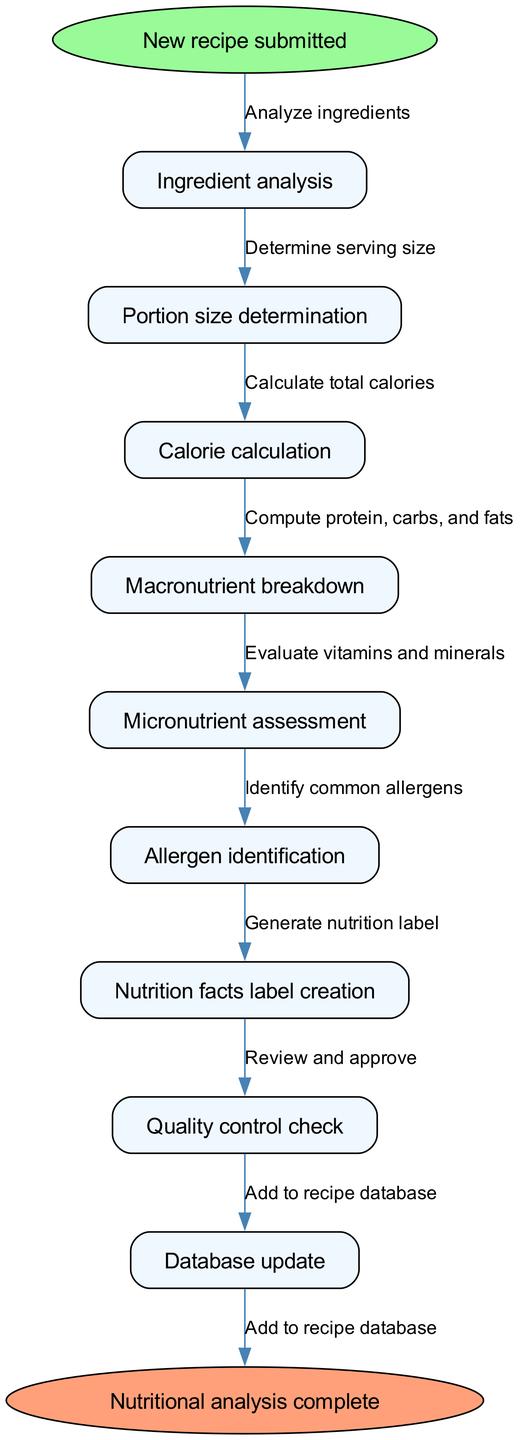What is the first step in the nutritional analysis process? The first step in the process is represented by the start node, which indicates that the "New recipe submitted" marks the beginning of the analysis.
Answer: New recipe submitted How many nodes are there in total? The diagram lists a total of 9 nodes, including the start and end nodes. This includes 7 process nodes and 2 terminal nodes.
Answer: 9 What is the last step before completion? The last step before reaching the end of the flowchart is the "Quality control check" node, which is the second to last node in the sequence.
Answer: Quality control check What is the focus of the “Micronutrient assessment” node? The “Micronutrient assessment” step evaluates specific vitamins and minerals present in the ingredients of the new recipe.
Answer: Vitamins and minerals Which process node follows 'Calorie calculation'? The node that follows 'Calorie calculation' is 'Macronutrient breakdown', indicating the next stage in the analysis after calories have been computed.
Answer: Macronutrient breakdown What is the relationship between "Ingredient analysis" and "Nutrition facts label creation"? The flow of the diagram shows that first, ingredients are analyzed, which generates data that eventually leads to the creation of the nutrition facts label, thus establishing a direct sequential relationship between the two nodes.
Answer: Sequential relationship How many edges connect the nodes in the diagram? The total number of edges in the flowchart is 8. Each edge represents a direct connection indicating the progression from one process to the next, starting from the initial node to the ending node.
Answer: 8 What indicates the completion of the process? The completion of the process is indicated by the end node labeled "Nutritional analysis complete", confirming that all analysis steps have been successfully finished.
Answer: Nutritional analysis complete Which node is responsible for identifying allergens? The node labeled "Allergen identification" is specifically tasked with pinpointing any common allergens present in the recipe ingredients during the analysis.
Answer: Allergen identification 